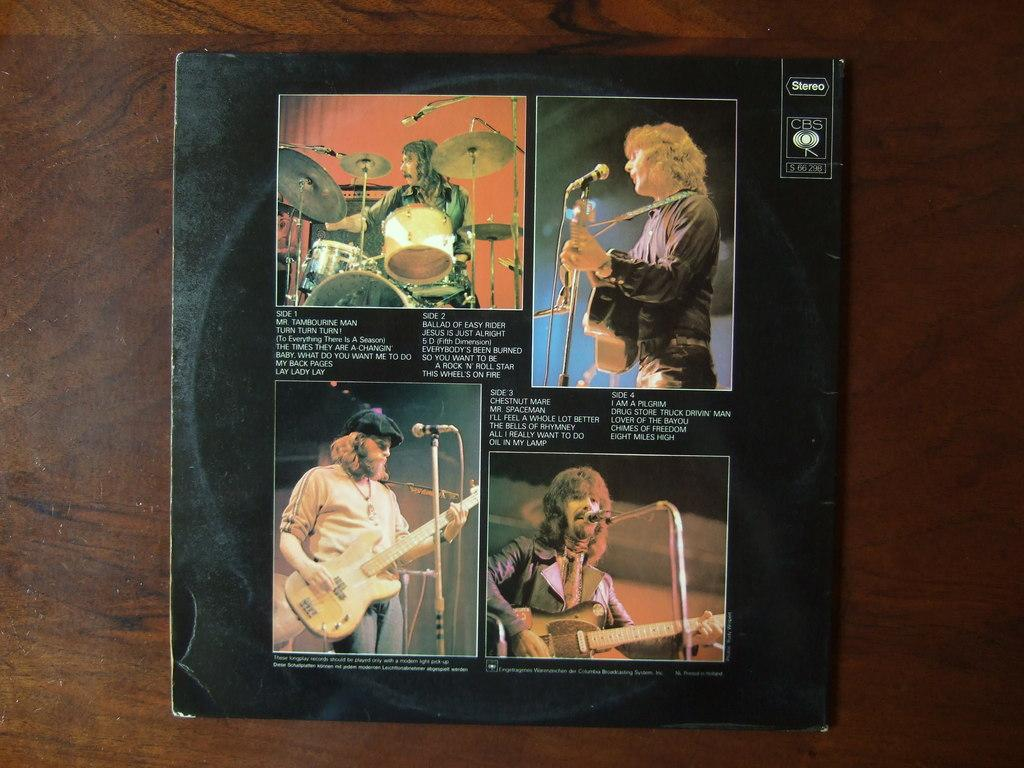<image>
Write a terse but informative summary of the picture. An album cover that includes songs like Mr. Tambourine Man. 